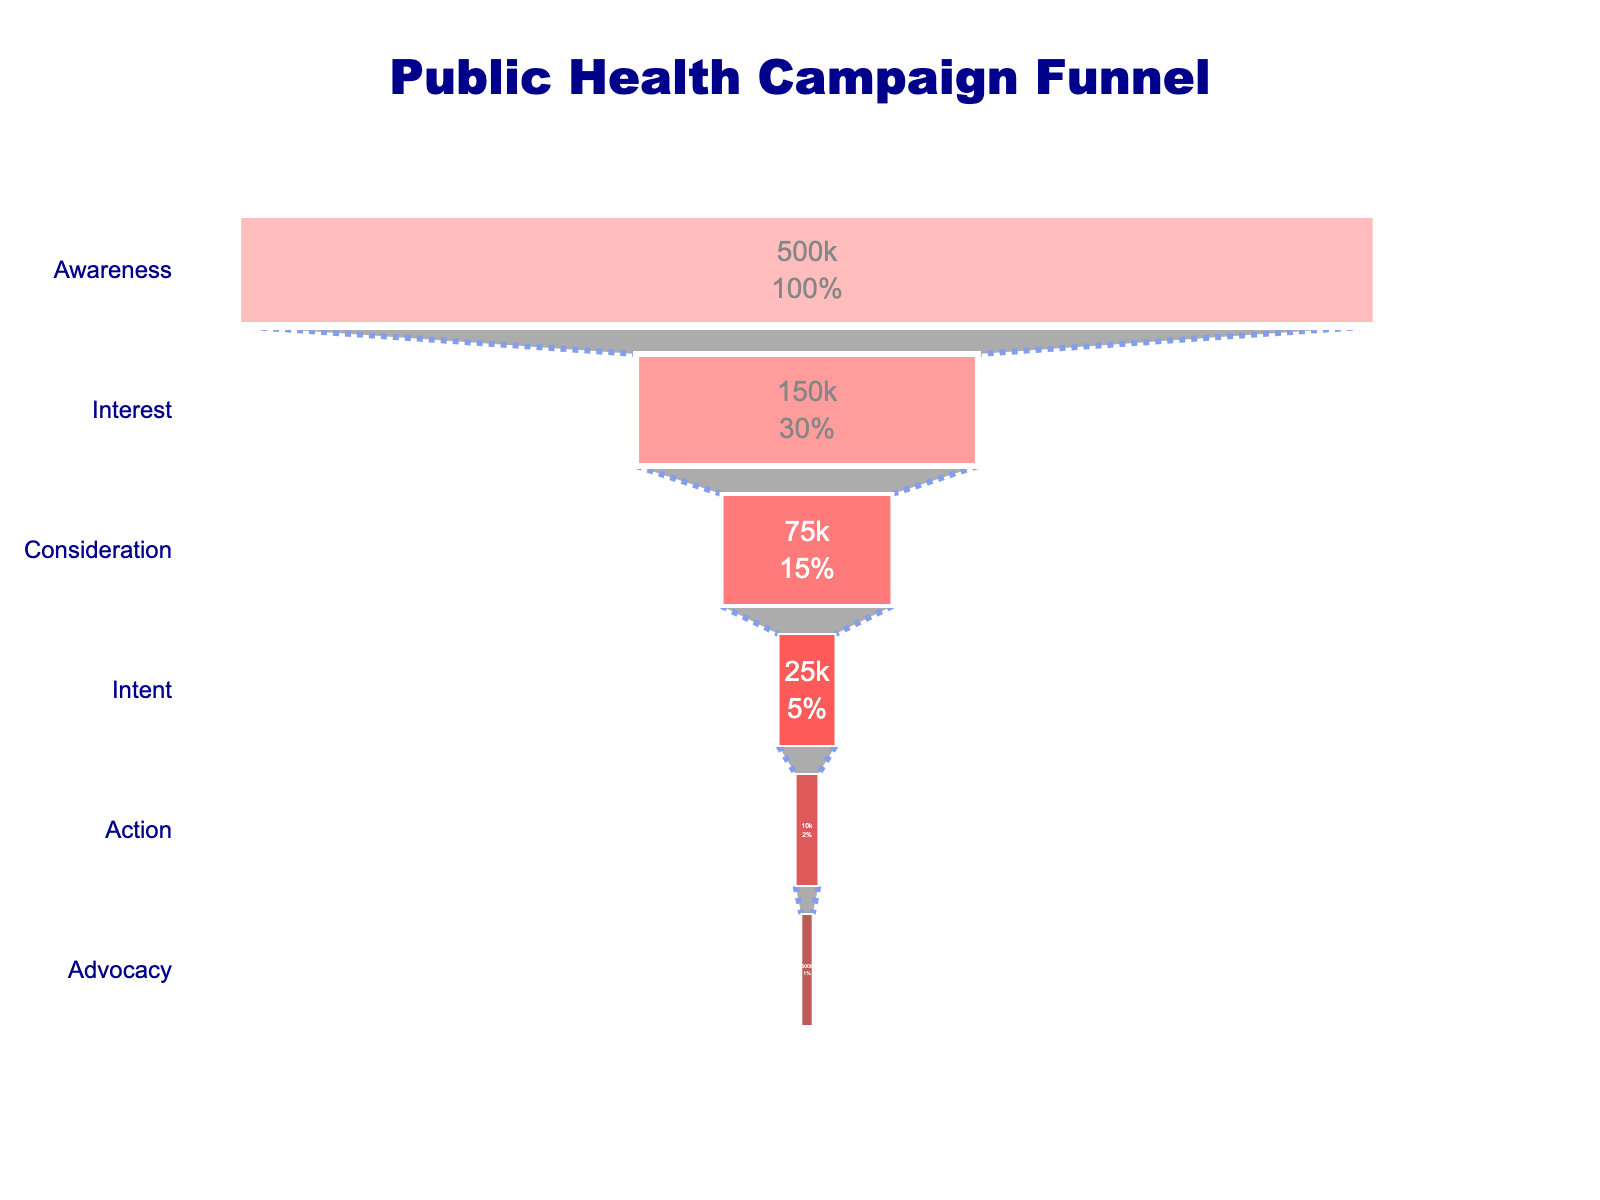What stage has the largest audience count? The largest audience count is at the "Awareness" stage, which shows the total population reached by the campaign.
Answer: Awareness What is the title of the chart? The title of the chart is displayed at the top. It is "Public Health Campaign Funnel."
Answer: Public Health Campaign Funnel How many people scheduled vaccine appointments? Look at the "Vaccine appointments scheduled" stage. It shows 10,000 people.
Answer: 10,000 What is the color of the "Interest" stage? The color associated with the "Interest" stage, or website visitors, is a light red shade.
Answer: Light red What percentage of the initial audience transitioned to email subscribers? The email subscribers count is 75,000 out of the total 500,000 reached, which is 75,000/500,000 * 100 = 15%.
Answer: 15% Compare the audience count of "Consideration" and "Intent" stages. Which one is larger? The "Consideration" stage (email subscribers) has 75,000 people, whereas the "Intent" stage (workshop attendees) has 25,000 people. So, Consideration is larger.
Answer: Consideration How many stages are there in total in the funnel? Count the number of different stages represented in the funnel chart. There are six stages: Awareness, Interest, Consideration, Intent, Action, Advocacy.
Answer: Six What is the difference in count between "Interest" and "Consideration" stages? The number of website visitors (Interest) is 150,000, and the number of email subscribers (Consideration) is 75,000. The difference is 150,000 - 75,000 = 75,000.
Answer: 75,000 What is the final stage in the funnel? The final stage in the funnel is the one at the bottom of the chart, labeled as "Positive social media mentions".
Answer: Advocacy 